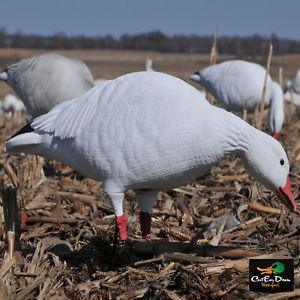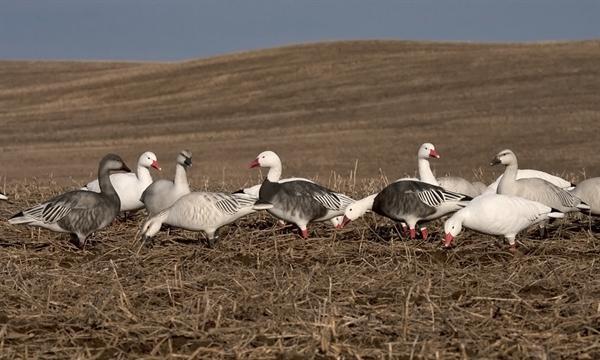The first image is the image on the left, the second image is the image on the right. Considering the images on both sides, is "Two birds in the left image have dark bodies and white heads." valid? Answer yes or no. No. 